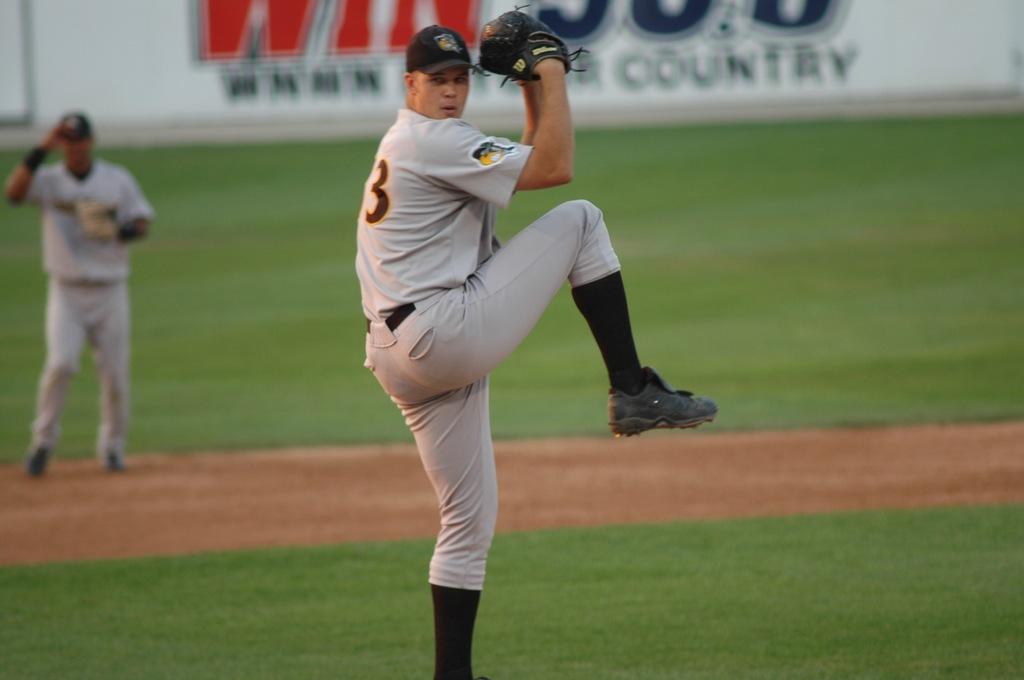Is the word country mentioned behind the player?
Your response must be concise. Yes. 